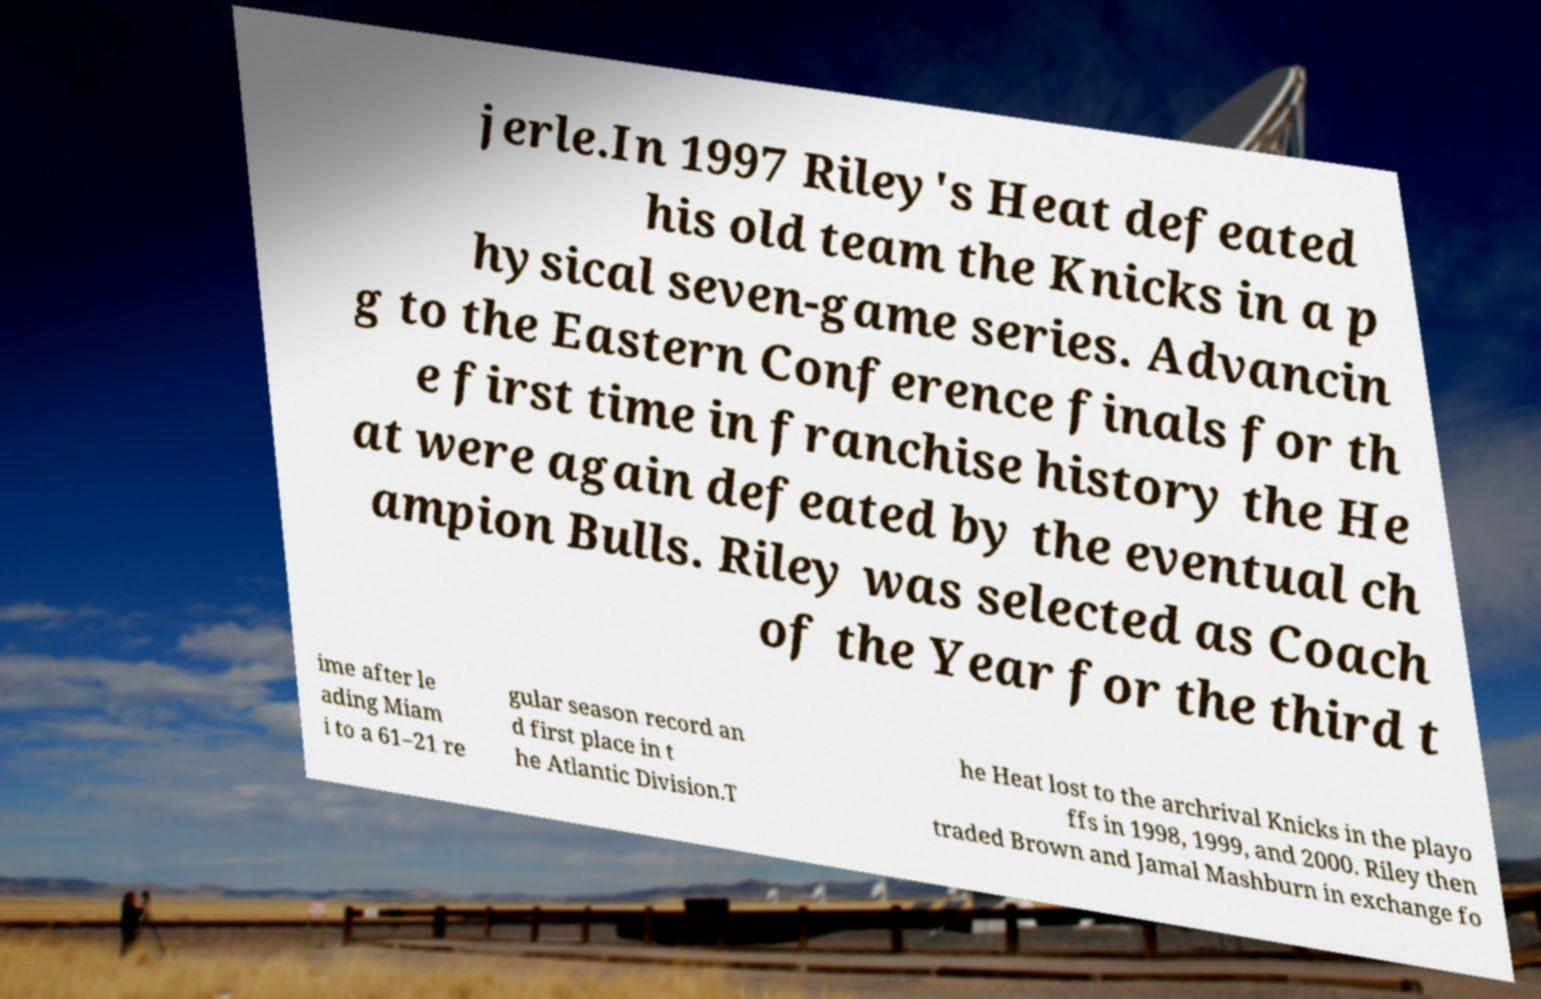What messages or text are displayed in this image? I need them in a readable, typed format. jerle.In 1997 Riley's Heat defeated his old team the Knicks in a p hysical seven-game series. Advancin g to the Eastern Conference finals for th e first time in franchise history the He at were again defeated by the eventual ch ampion Bulls. Riley was selected as Coach of the Year for the third t ime after le ading Miam i to a 61–21 re gular season record an d first place in t he Atlantic Division.T he Heat lost to the archrival Knicks in the playo ffs in 1998, 1999, and 2000. Riley then traded Brown and Jamal Mashburn in exchange fo 